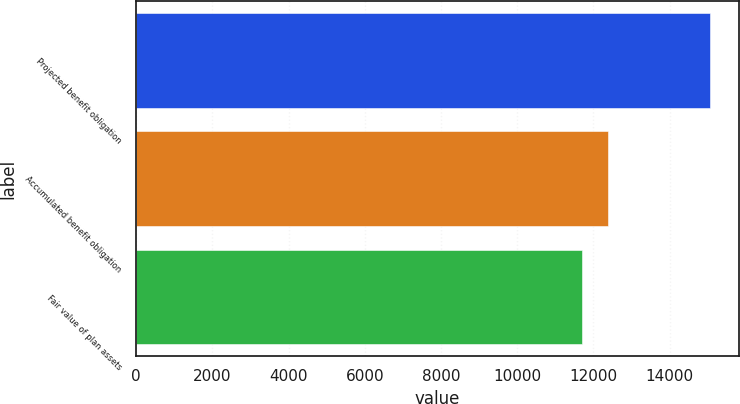<chart> <loc_0><loc_0><loc_500><loc_500><bar_chart><fcel>Projected benefit obligation<fcel>Accumulated benefit obligation<fcel>Fair value of plan assets<nl><fcel>15067<fcel>12396<fcel>11702<nl></chart> 